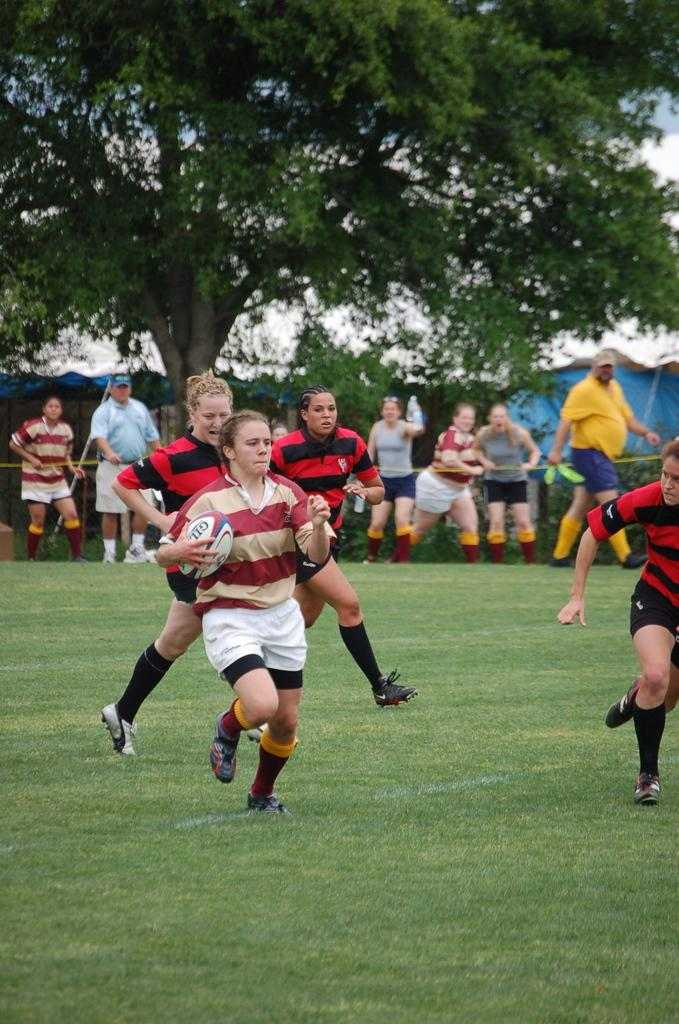How many people are visible in the image? There are people in the image, but the exact number is not specified. What is one person doing in the image? One person is holding a ball. Can you describe the people behind the person holding the ball? There are other people behind the person holding the ball, but their actions or appearance are not mentioned. What type of natural elements can be seen in the image? There are trees and plants in the image. What type of rabbit can be seen washing its paws in the image? There is no rabbit present in the image, and therefore no such activity can be observed. 